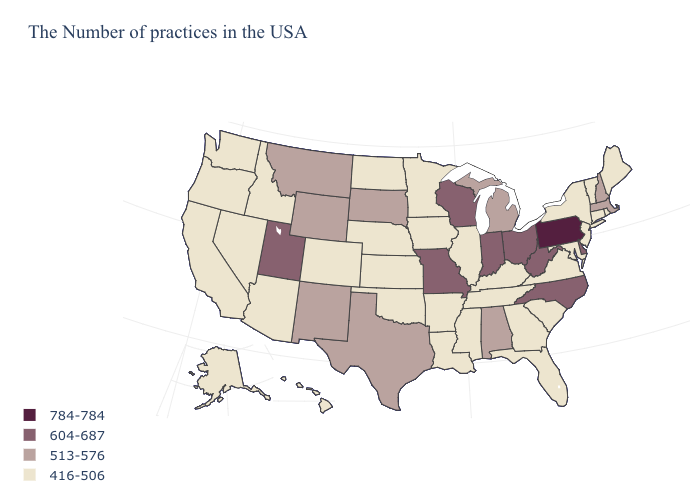Name the states that have a value in the range 604-687?
Give a very brief answer. Delaware, North Carolina, West Virginia, Ohio, Indiana, Wisconsin, Missouri, Utah. What is the value of Kentucky?
Short answer required. 416-506. Does Wisconsin have the lowest value in the MidWest?
Answer briefly. No. Which states have the lowest value in the West?
Give a very brief answer. Colorado, Arizona, Idaho, Nevada, California, Washington, Oregon, Alaska, Hawaii. Name the states that have a value in the range 784-784?
Answer briefly. Pennsylvania. Name the states that have a value in the range 784-784?
Quick response, please. Pennsylvania. Does the map have missing data?
Short answer required. No. Which states have the lowest value in the USA?
Short answer required. Maine, Rhode Island, Vermont, Connecticut, New York, New Jersey, Maryland, Virginia, South Carolina, Florida, Georgia, Kentucky, Tennessee, Illinois, Mississippi, Louisiana, Arkansas, Minnesota, Iowa, Kansas, Nebraska, Oklahoma, North Dakota, Colorado, Arizona, Idaho, Nevada, California, Washington, Oregon, Alaska, Hawaii. Which states hav the highest value in the South?
Short answer required. Delaware, North Carolina, West Virginia. Among the states that border Florida , which have the highest value?
Be succinct. Alabama. Which states hav the highest value in the South?
Be succinct. Delaware, North Carolina, West Virginia. What is the value of New Jersey?
Keep it brief. 416-506. Does California have the same value as Washington?
Keep it brief. Yes. How many symbols are there in the legend?
Quick response, please. 4. Which states hav the highest value in the South?
Answer briefly. Delaware, North Carolina, West Virginia. 